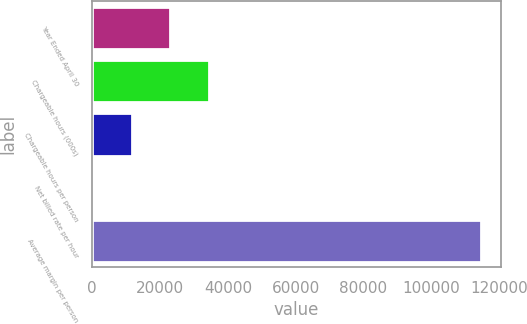Convert chart to OTSL. <chart><loc_0><loc_0><loc_500><loc_500><bar_chart><fcel>Year Ended April 30<fcel>Chargeable hours (000s)<fcel>Chargeable hours per person<fcel>Net billed rate per hour<fcel>Average margin per person<nl><fcel>23063.8<fcel>34525.2<fcel>11602.4<fcel>141<fcel>114755<nl></chart> 